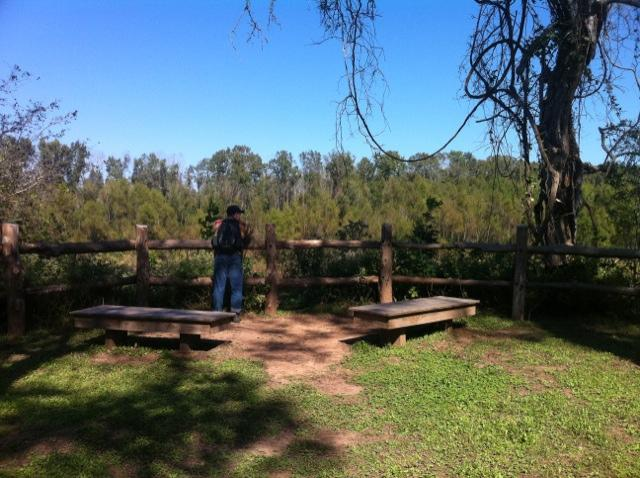What is the person leaning against? fence 